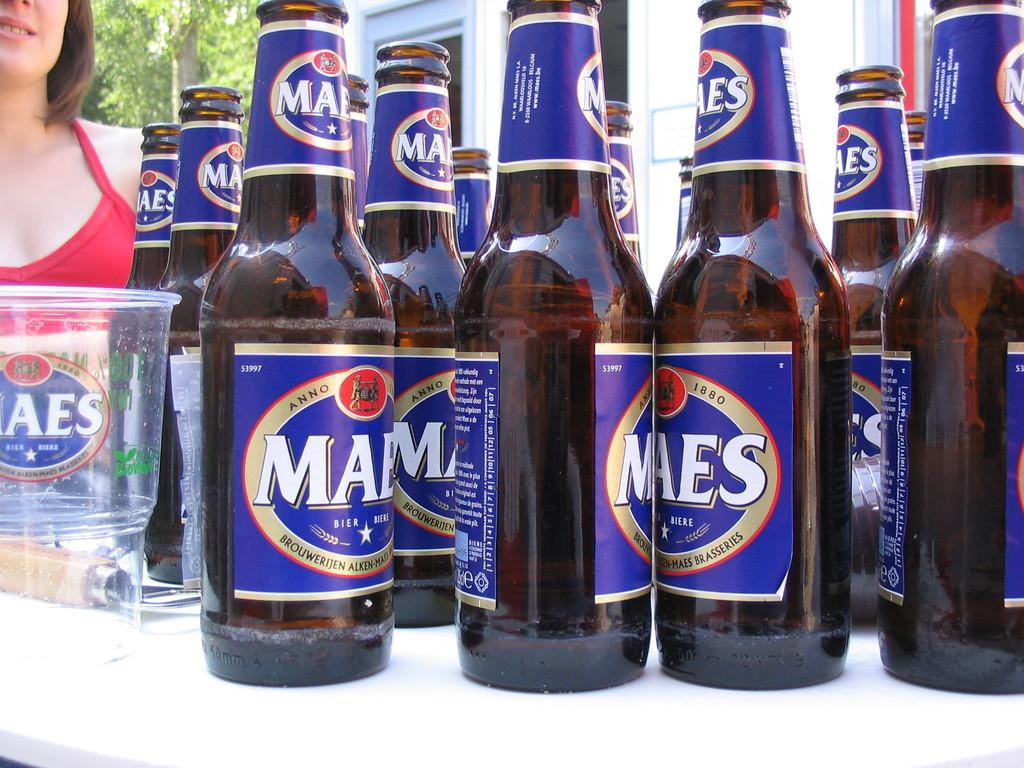<image>
Write a terse but informative summary of the picture. Several brown glass bottles of Maes beer with blue labels. 